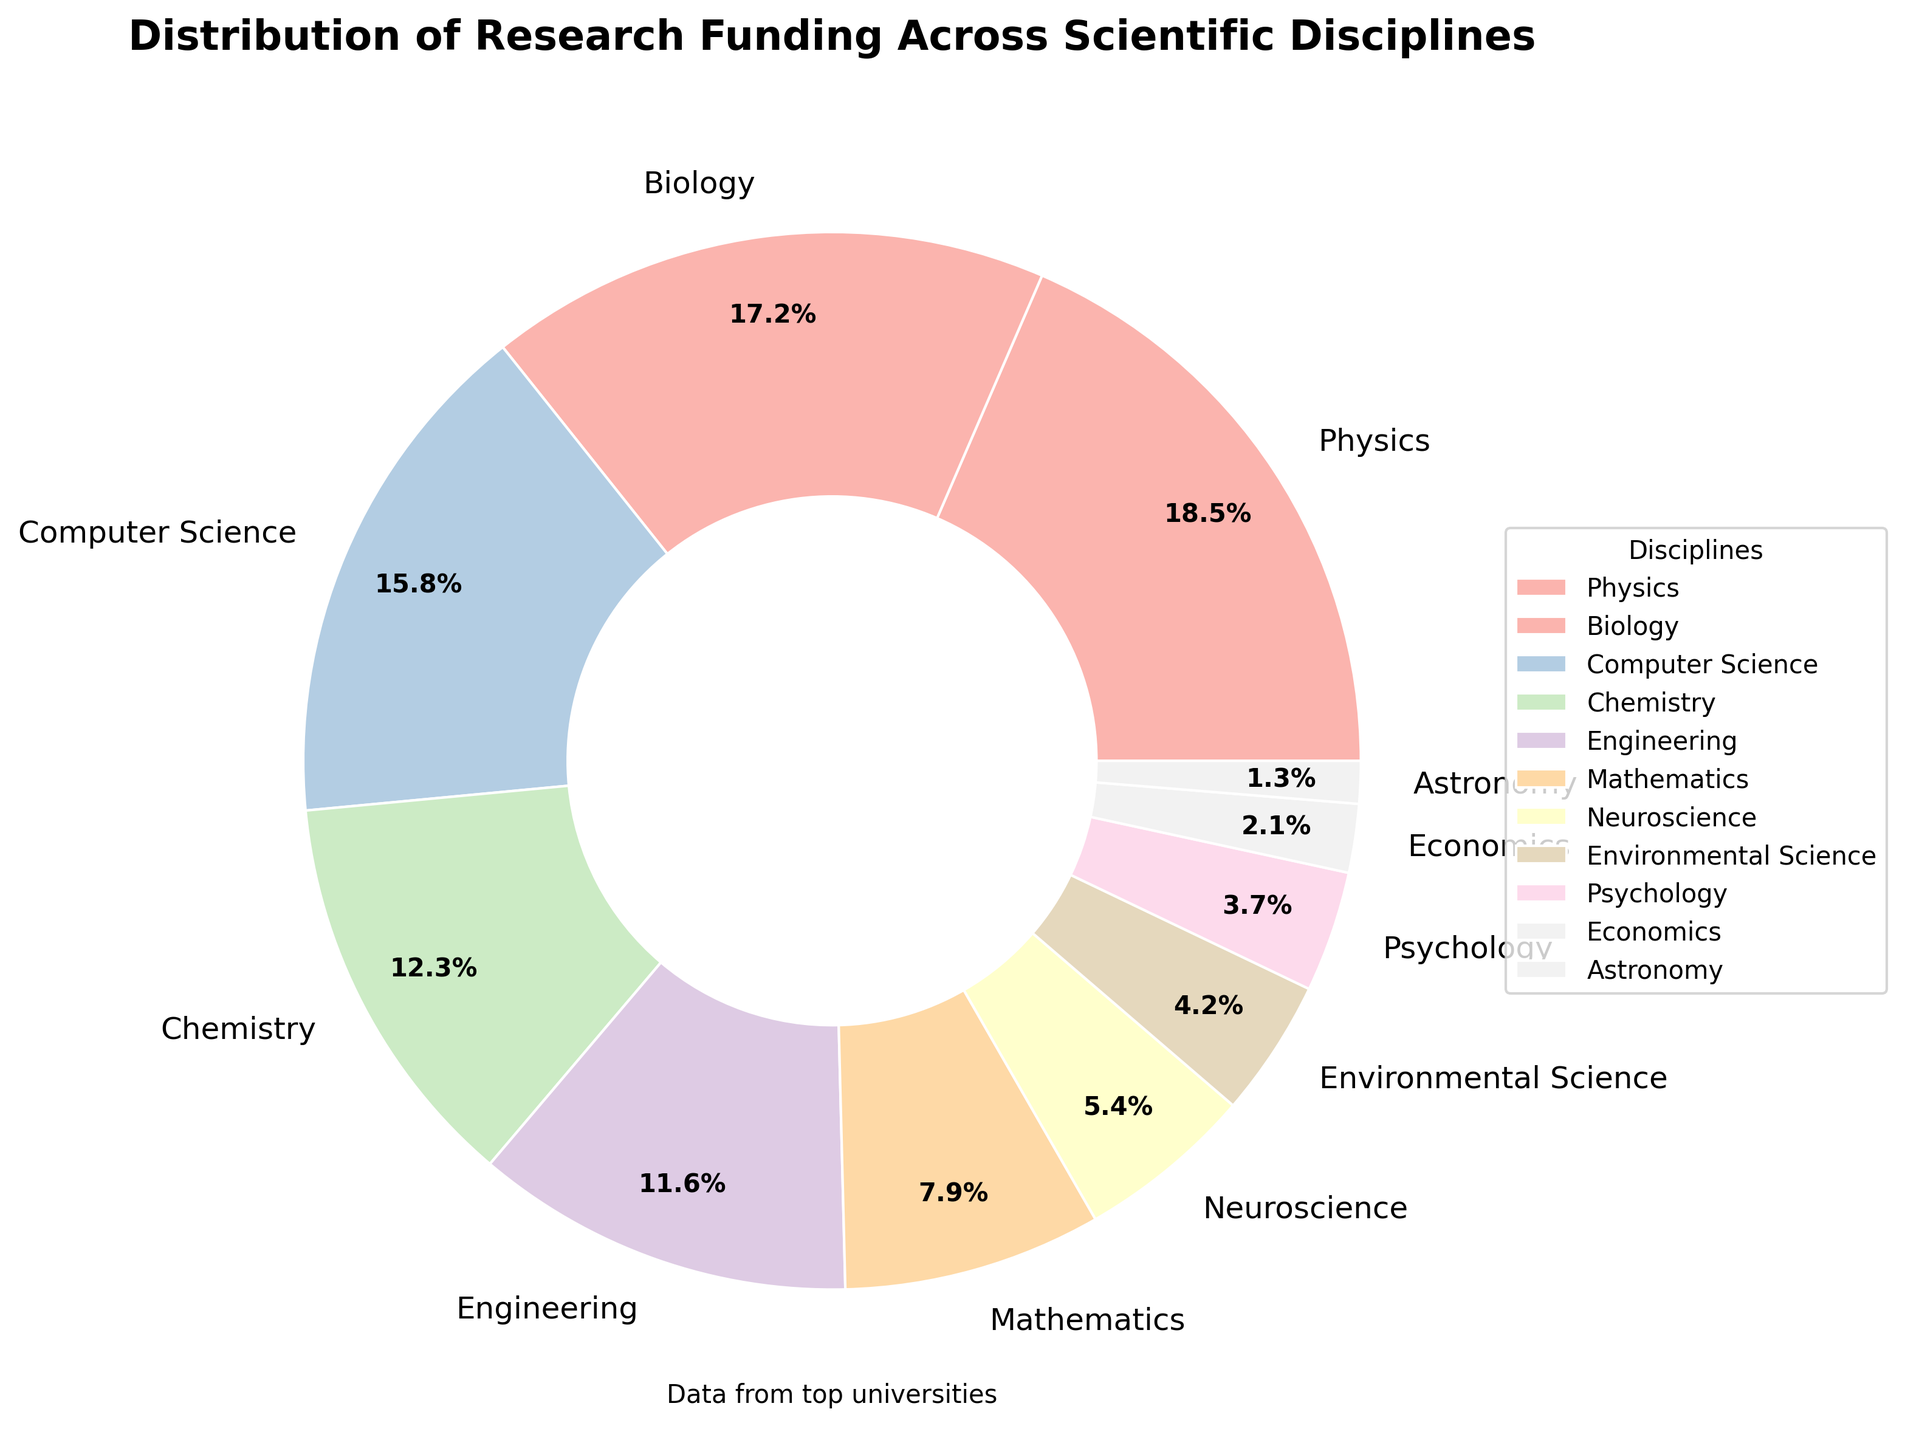Which discipline receives the highest percentage of research funding? The pie chart shows that Physics has the largest wedge, representing 18.5% of the total funding.
Answer: Physics Which discipline receives the lowest percentage of research funding? The smallest wedge in the pie chart corresponds to Astronomy, which receives 1.3% of the total funding.
Answer: Astronomy What is the combined percentage of research funding for the top three disciplines? The top three disciplines by funding are Physics (18.5%), Biology (17.2%), and Computer Science (15.8%). Adding these percentages gives 18.5 + 17.2 + 15.8 = 51.5%
Answer: 51.5% How much less funding does Psychology receive compared to Chemistry? Chemistry receives 12.3% of the funding, while Psychology receives 3.7%. The difference in funding is 12.3 - 3.7 = 8.6%.
Answer: 8.6% Which disciplines together account for approximately one-third of the total funding? To find the disciplines that sum to about 33.3%, we can start adding from the lower percentages: Neuroscience (5.4%), Environmental Science (4.2%), Psychology (3.7%), Economics (2.1%), and Astronomy (1.3%). Adding these gives 5.4 + 4.2 + 3.7 + 2.1 + 1.3 = 16.7%. This is approximately half of one-third. Increasing by adding Mathematics (7.9%) and Engineering (11.6%) gives 16.7 + 7.9 + 11.6 = 36.2%, which is closest to one-third. So the disciplines are Neuroscience, Environmental Science, Psychology, Economics, and Astronomy.
Answer: Neuroscience, Environmental Science, Psychology, Economics, Astronomy Does Biology receive more funding than Mathematics and Psychology combined? Biology receives 17.2% of the funding. Mathematics receives 7.9%, and Psychology receives 3.7%. Adding Mathematics and Psychology together gives 7.9 + 3.7 = 11.6%. Since 17.2% (Biology) is greater than 11.6%, the answer is yes.
Answer: Yes How does the funding for Computer Science compare to that of Neuroscience and Engineering combined? Computer Science receives 15.8% funding. Neuroscience receives 5.4%, and Engineering receives 11.6%. Adding Neuroscience and Engineering together gives 5.4 + 11.6 = 17.0%. Since 15.8% (Computer Science) is less than 17.0%, the funding for Computer Science is lower.
Answer: Lower Which discipline has a funding percentage that is closest to the average funding percentage of all disciplines? To determine the average funding percentage, we first sum all the percentages: 18.5 + 17.2 + 15.8 + 12.3 + 11.6 + 7.9 + 5.4 + 4.2 + 3.7 + 2.1 + 1.3 = 100%. Since there are 11 disciplines, the average is 100% / 11 ≈ 9.1%. The discipline closest to this average is Mathematics with 7.9%.
Answer: Mathematics What percentage of total funding is allocated to disciplines outside the top five? The top five disciplines are Physics (18.5%), Biology (17.2%), Computer Science (15.8%), Chemistry (12.3%), and Engineering (11.6%). Their combined funding is 18.5 + 17.2 + 15.8 + 12.3 + 11.6 = 75.4%. Therefore, the percentage allocated to the remaining disciplines is 100 - 75.4 = 24.6%.
Answer: 24.6% 